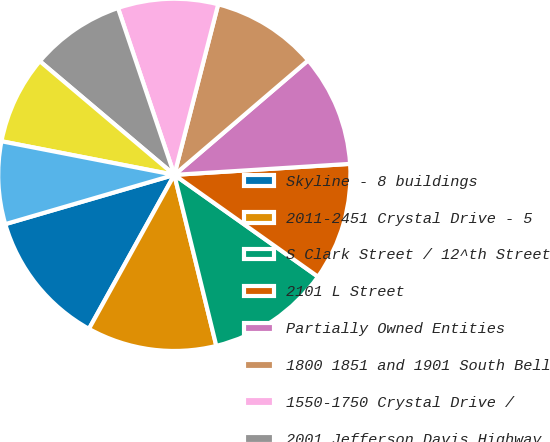<chart> <loc_0><loc_0><loc_500><loc_500><pie_chart><fcel>Skyline - 8 buildings<fcel>2011-2451 Crystal Drive - 5<fcel>S Clark Street / 12^th Street<fcel>2101 L Street<fcel>Partially Owned Entities<fcel>1800 1851 and 1901 South Bell<fcel>1550-1750 Crystal Drive /<fcel>2001 Jefferson Davis Highway<fcel>Universal Building South<fcel>Courthouse Plaza<nl><fcel>12.43%<fcel>11.89%<fcel>11.35%<fcel>10.81%<fcel>10.27%<fcel>9.73%<fcel>9.19%<fcel>8.65%<fcel>8.11%<fcel>7.57%<nl></chart> 